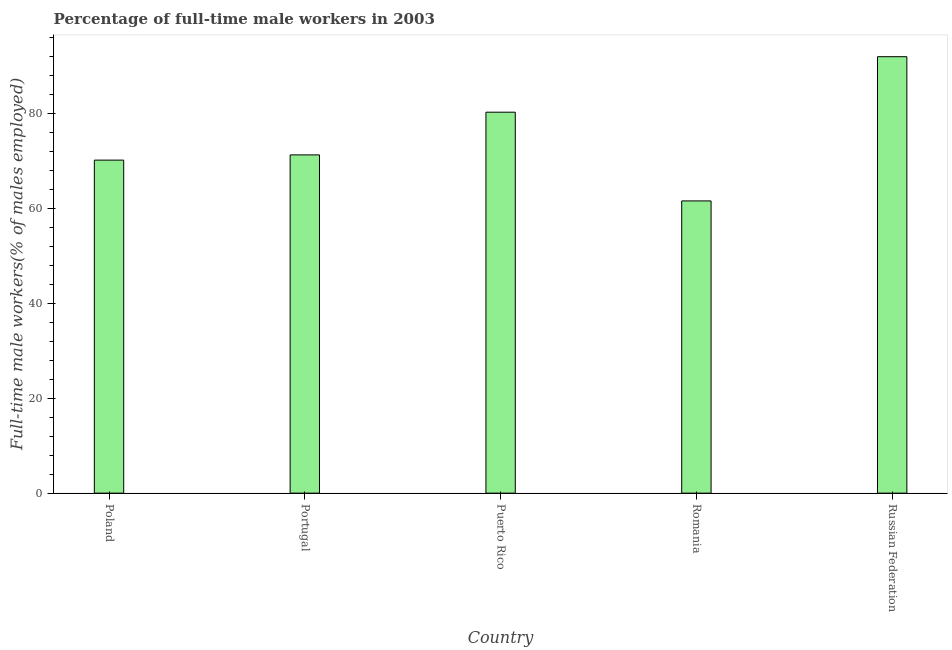Does the graph contain any zero values?
Keep it short and to the point. No. What is the title of the graph?
Provide a short and direct response. Percentage of full-time male workers in 2003. What is the label or title of the Y-axis?
Provide a succinct answer. Full-time male workers(% of males employed). What is the percentage of full-time male workers in Poland?
Keep it short and to the point. 70.2. Across all countries, what is the maximum percentage of full-time male workers?
Make the answer very short. 92. Across all countries, what is the minimum percentage of full-time male workers?
Make the answer very short. 61.6. In which country was the percentage of full-time male workers maximum?
Your response must be concise. Russian Federation. In which country was the percentage of full-time male workers minimum?
Your response must be concise. Romania. What is the sum of the percentage of full-time male workers?
Your answer should be compact. 375.4. What is the difference between the percentage of full-time male workers in Portugal and Russian Federation?
Provide a short and direct response. -20.7. What is the average percentage of full-time male workers per country?
Provide a succinct answer. 75.08. What is the median percentage of full-time male workers?
Offer a terse response. 71.3. What is the ratio of the percentage of full-time male workers in Poland to that in Romania?
Provide a succinct answer. 1.14. Is the percentage of full-time male workers in Puerto Rico less than that in Romania?
Offer a terse response. No. Is the difference between the percentage of full-time male workers in Puerto Rico and Russian Federation greater than the difference between any two countries?
Your response must be concise. No. What is the difference between the highest and the lowest percentage of full-time male workers?
Your answer should be very brief. 30.4. In how many countries, is the percentage of full-time male workers greater than the average percentage of full-time male workers taken over all countries?
Your answer should be compact. 2. Are the values on the major ticks of Y-axis written in scientific E-notation?
Provide a succinct answer. No. What is the Full-time male workers(% of males employed) of Poland?
Provide a succinct answer. 70.2. What is the Full-time male workers(% of males employed) of Portugal?
Make the answer very short. 71.3. What is the Full-time male workers(% of males employed) in Puerto Rico?
Offer a terse response. 80.3. What is the Full-time male workers(% of males employed) of Romania?
Your answer should be compact. 61.6. What is the Full-time male workers(% of males employed) in Russian Federation?
Your response must be concise. 92. What is the difference between the Full-time male workers(% of males employed) in Poland and Portugal?
Keep it short and to the point. -1.1. What is the difference between the Full-time male workers(% of males employed) in Poland and Puerto Rico?
Offer a very short reply. -10.1. What is the difference between the Full-time male workers(% of males employed) in Poland and Russian Federation?
Keep it short and to the point. -21.8. What is the difference between the Full-time male workers(% of males employed) in Portugal and Romania?
Your answer should be compact. 9.7. What is the difference between the Full-time male workers(% of males employed) in Portugal and Russian Federation?
Give a very brief answer. -20.7. What is the difference between the Full-time male workers(% of males employed) in Puerto Rico and Romania?
Provide a short and direct response. 18.7. What is the difference between the Full-time male workers(% of males employed) in Puerto Rico and Russian Federation?
Your response must be concise. -11.7. What is the difference between the Full-time male workers(% of males employed) in Romania and Russian Federation?
Keep it short and to the point. -30.4. What is the ratio of the Full-time male workers(% of males employed) in Poland to that in Portugal?
Offer a very short reply. 0.98. What is the ratio of the Full-time male workers(% of males employed) in Poland to that in Puerto Rico?
Give a very brief answer. 0.87. What is the ratio of the Full-time male workers(% of males employed) in Poland to that in Romania?
Offer a terse response. 1.14. What is the ratio of the Full-time male workers(% of males employed) in Poland to that in Russian Federation?
Give a very brief answer. 0.76. What is the ratio of the Full-time male workers(% of males employed) in Portugal to that in Puerto Rico?
Your answer should be compact. 0.89. What is the ratio of the Full-time male workers(% of males employed) in Portugal to that in Romania?
Give a very brief answer. 1.16. What is the ratio of the Full-time male workers(% of males employed) in Portugal to that in Russian Federation?
Your answer should be compact. 0.78. What is the ratio of the Full-time male workers(% of males employed) in Puerto Rico to that in Romania?
Ensure brevity in your answer.  1.3. What is the ratio of the Full-time male workers(% of males employed) in Puerto Rico to that in Russian Federation?
Offer a very short reply. 0.87. What is the ratio of the Full-time male workers(% of males employed) in Romania to that in Russian Federation?
Keep it short and to the point. 0.67. 